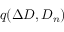<formula> <loc_0><loc_0><loc_500><loc_500>q ( \Delta D , D _ { n } )</formula> 